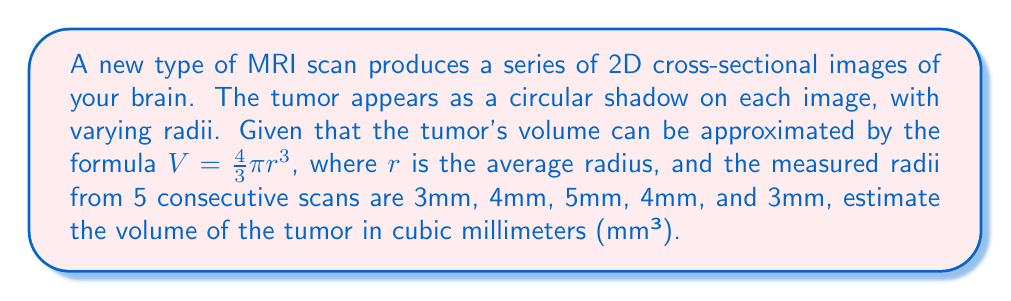Could you help me with this problem? To solve this problem, we'll follow these steps:

1. Calculate the average radius:
   $r_{avg} = \frac{3 + 4 + 5 + 4 + 3}{5} = \frac{19}{5} = 3.8$ mm

2. Use the volume formula with the average radius:
   $V = \frac{4}{3}\pi r^3$
   $V = \frac{4}{3}\pi (3.8)^3$

3. Simplify the calculation:
   $V = \frac{4}{3}\pi (54.872)$
   $V = 4\pi (18.29067)$
   $V \approx 229.97$ mm³

4. Round to the nearest whole number:
   $V \approx 230$ mm³

This estimation method assumes that the tumor is roughly spherical, which is a common simplification in medical imaging analysis for small tumors.
Answer: 230 mm³ 